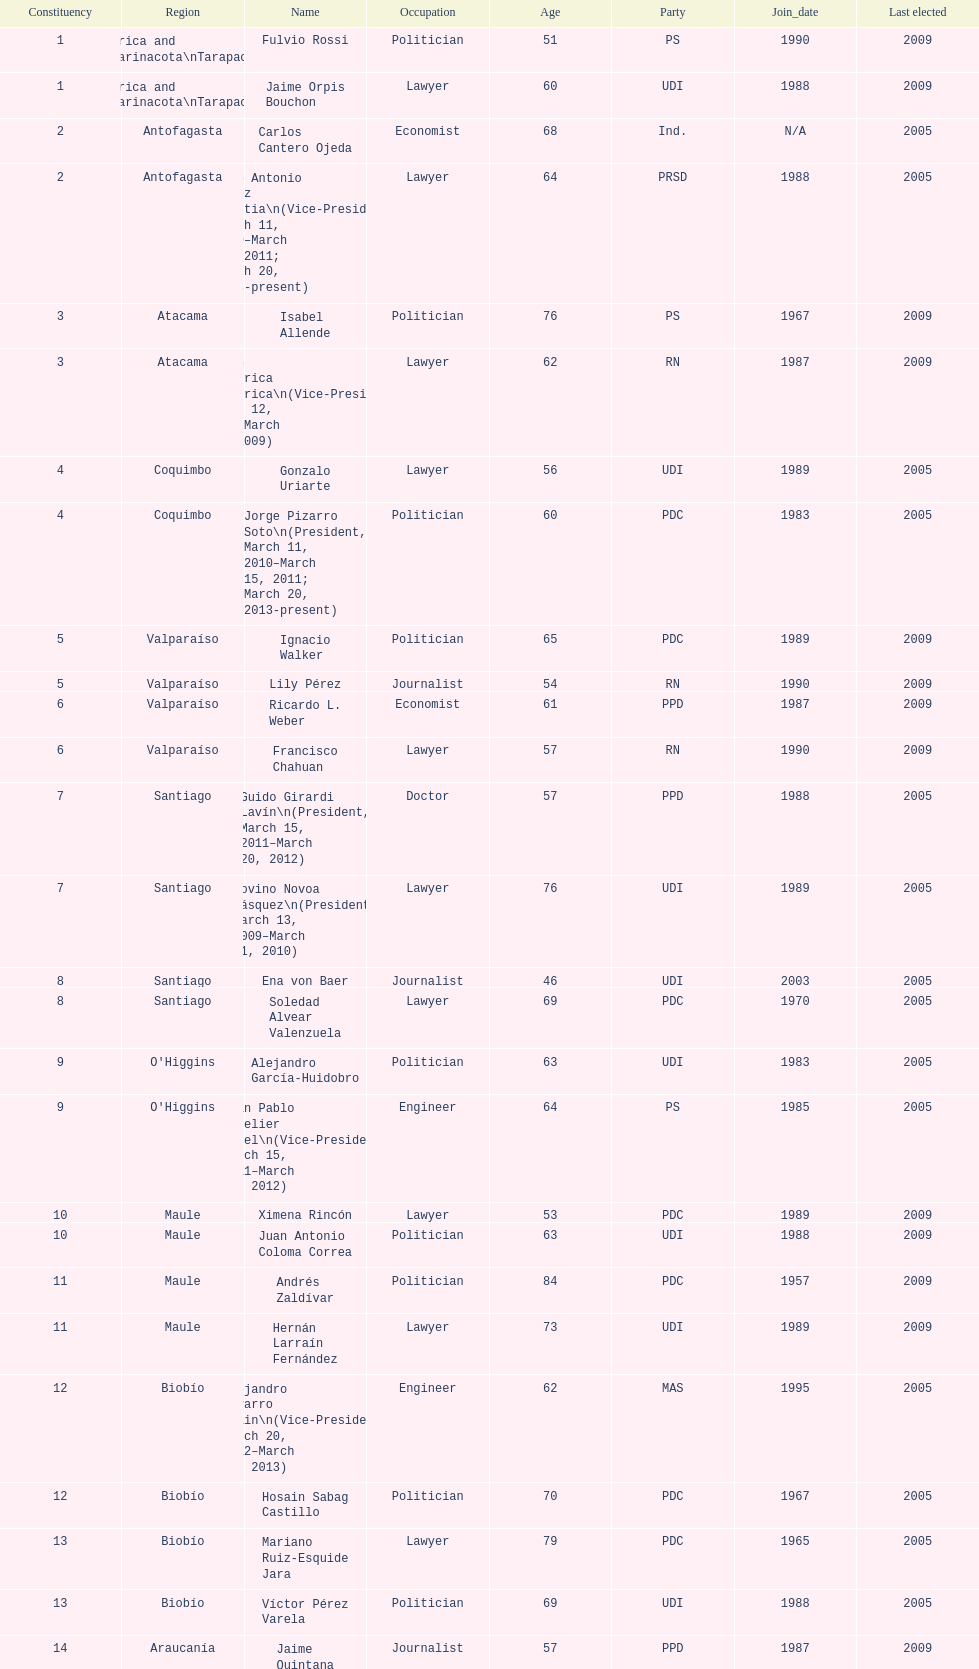Which party did jaime quintana belong to? PPD. 